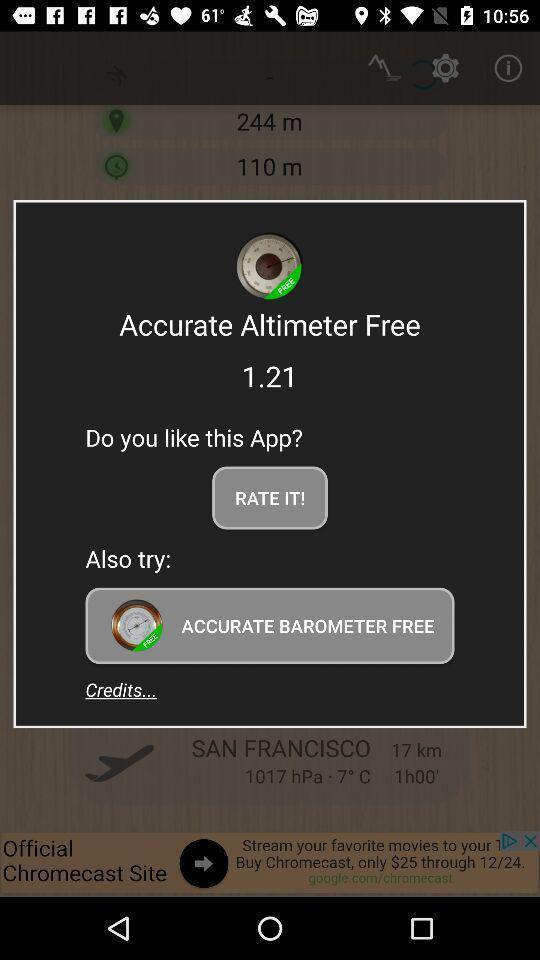Please provide a description for this image. Pop up page for rating an app. 